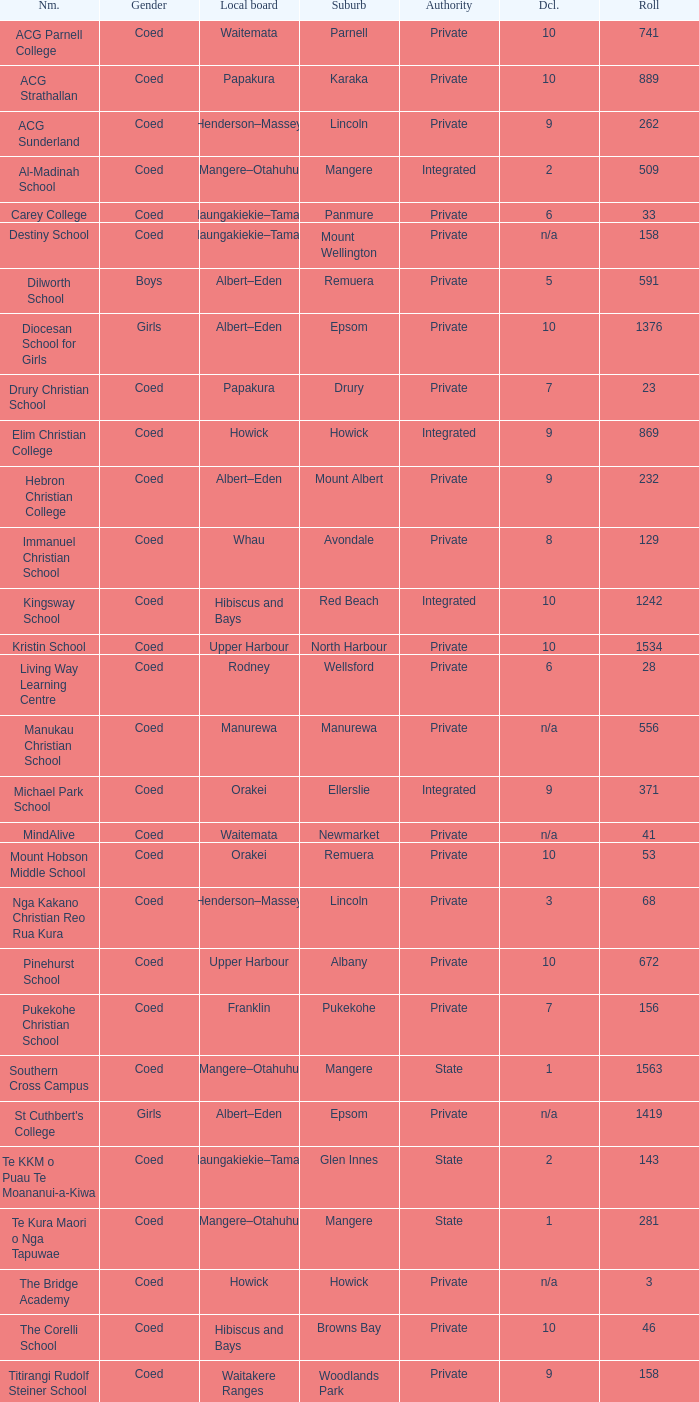What gender has a local board of albert–eden with a roll of more than 232 and Decile of 5? Boys. 